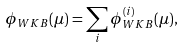<formula> <loc_0><loc_0><loc_500><loc_500>\phi _ { W K B } ( \mu ) = \sum _ { i } \phi _ { W K B } ^ { ( i ) } ( \mu ) ,</formula> 